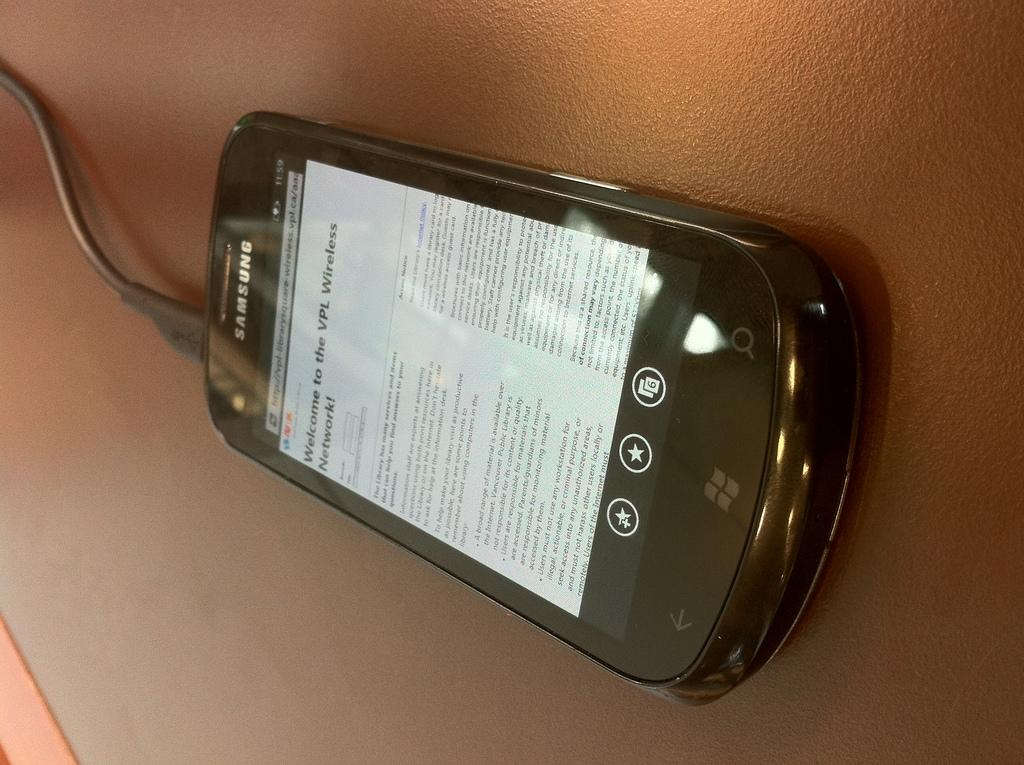<image>
Share a concise interpretation of the image provided. A samsung branded cell phone with a vpl wireless log in screen. 